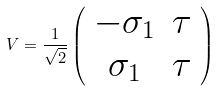Convert formula to latex. <formula><loc_0><loc_0><loc_500><loc_500>V = \frac { 1 } { \sqrt { 2 } } \left ( \begin{array} { c c } - \sigma _ { 1 } & \tau \\ \sigma _ { 1 } & \tau \end{array} \right )</formula> 